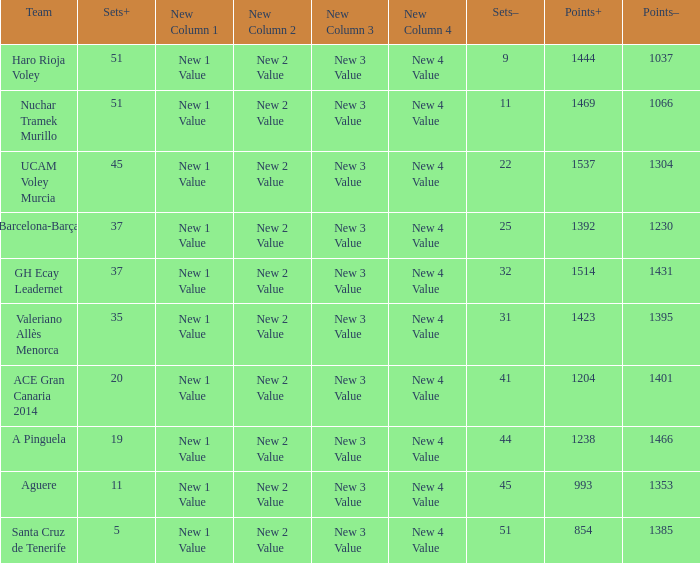Who is the team who had a Sets+ number smaller than 20, a Sets- number of 45, and a Points+ number smaller than 1238? Aguere. 